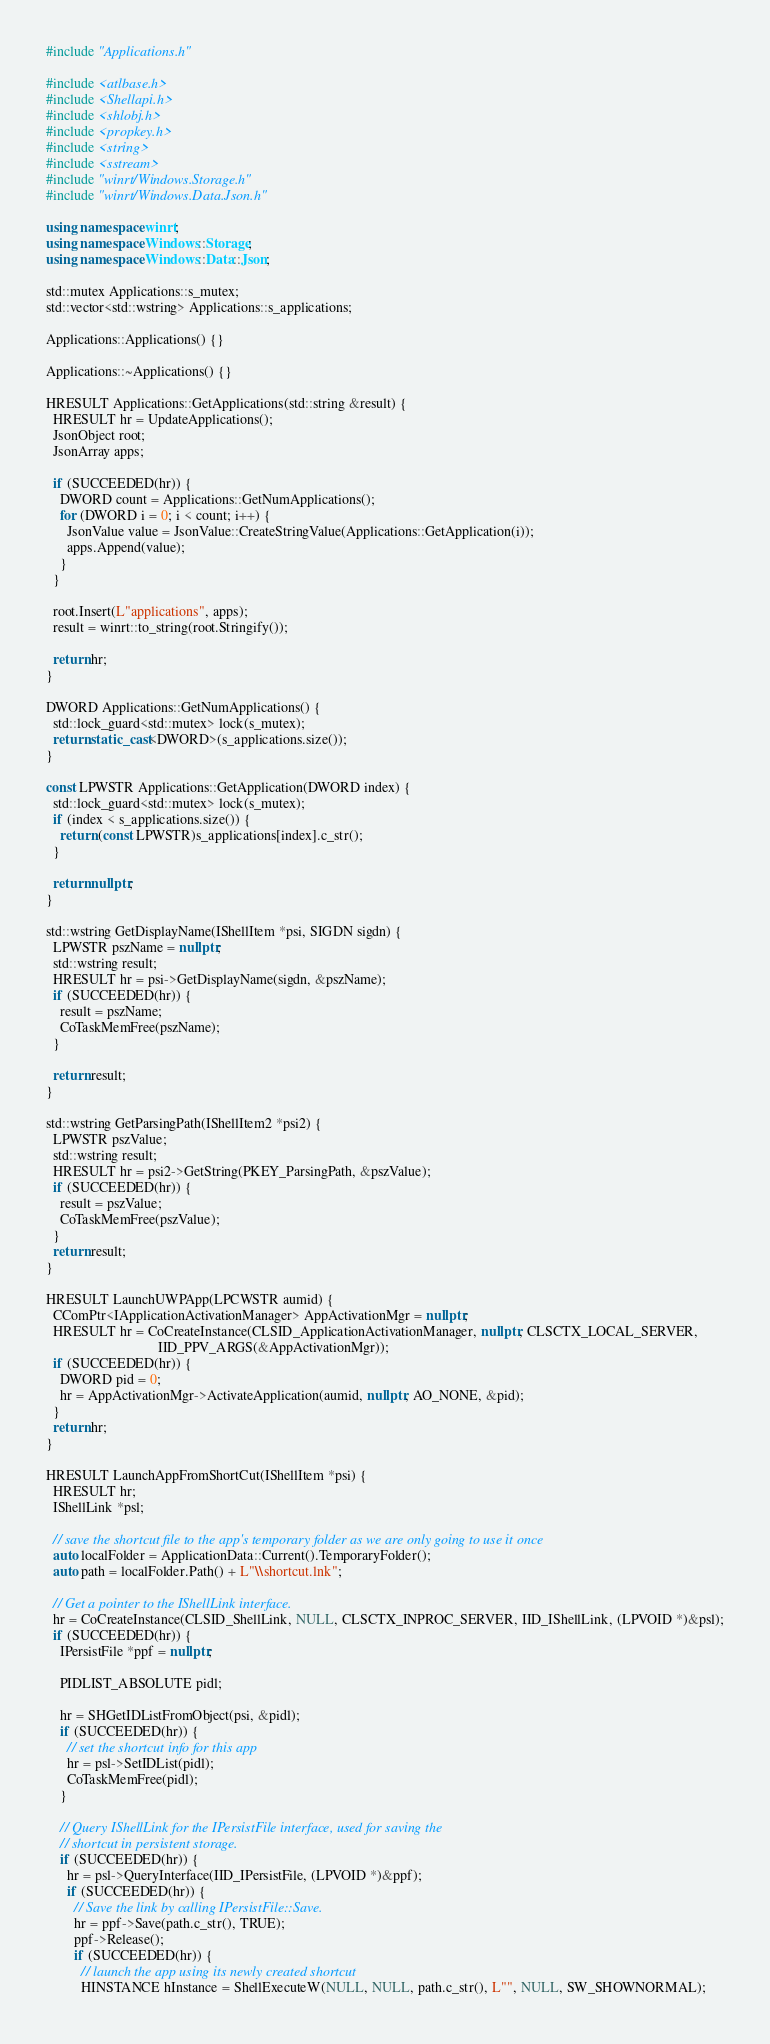<code> <loc_0><loc_0><loc_500><loc_500><_C++_>#include "Applications.h"

#include <atlbase.h>
#include <Shellapi.h>
#include <shlobj.h>
#include <propkey.h>
#include <string>
#include <sstream>
#include "winrt/Windows.Storage.h"
#include "winrt/Windows.Data.Json.h"

using namespace winrt;
using namespace Windows::Storage;
using namespace Windows::Data::Json;

std::mutex Applications::s_mutex;
std::vector<std::wstring> Applications::s_applications;

Applications::Applications() {}

Applications::~Applications() {}

HRESULT Applications::GetApplications(std::string &result) {
  HRESULT hr = UpdateApplications();
  JsonObject root;
  JsonArray apps;

  if (SUCCEEDED(hr)) {
    DWORD count = Applications::GetNumApplications();
    for (DWORD i = 0; i < count; i++) {
      JsonValue value = JsonValue::CreateStringValue(Applications::GetApplication(i));
      apps.Append(value);
    }
  }

  root.Insert(L"applications", apps);
  result = winrt::to_string(root.Stringify());

  return hr;
}

DWORD Applications::GetNumApplications() {
  std::lock_guard<std::mutex> lock(s_mutex);
  return static_cast<DWORD>(s_applications.size());
}

const LPWSTR Applications::GetApplication(DWORD index) {
  std::lock_guard<std::mutex> lock(s_mutex);
  if (index < s_applications.size()) {
    return (const LPWSTR)s_applications[index].c_str();
  }

  return nullptr;
}

std::wstring GetDisplayName(IShellItem *psi, SIGDN sigdn) {
  LPWSTR pszName = nullptr;
  std::wstring result;
  HRESULT hr = psi->GetDisplayName(sigdn, &pszName);
  if (SUCCEEDED(hr)) {
    result = pszName;
    CoTaskMemFree(pszName);
  }

  return result;
}

std::wstring GetParsingPath(IShellItem2 *psi2) {
  LPWSTR pszValue;
  std::wstring result;
  HRESULT hr = psi2->GetString(PKEY_ParsingPath, &pszValue);
  if (SUCCEEDED(hr)) {
    result = pszValue;
    CoTaskMemFree(pszValue);
  }
  return result;
}

HRESULT LaunchUWPApp(LPCWSTR aumid) {
  CComPtr<IApplicationActivationManager> AppActivationMgr = nullptr;
  HRESULT hr = CoCreateInstance(CLSID_ApplicationActivationManager, nullptr, CLSCTX_LOCAL_SERVER,
                                IID_PPV_ARGS(&AppActivationMgr));
  if (SUCCEEDED(hr)) {
    DWORD pid = 0;
    hr = AppActivationMgr->ActivateApplication(aumid, nullptr, AO_NONE, &pid);
  }
  return hr;
}

HRESULT LaunchAppFromShortCut(IShellItem *psi) {
  HRESULT hr;
  IShellLink *psl;

  // save the shortcut file to the app's temporary folder as we are only going to use it once
  auto localFolder = ApplicationData::Current().TemporaryFolder();
  auto path = localFolder.Path() + L"\\shortcut.lnk";

  // Get a pointer to the IShellLink interface.
  hr = CoCreateInstance(CLSID_ShellLink, NULL, CLSCTX_INPROC_SERVER, IID_IShellLink, (LPVOID *)&psl);
  if (SUCCEEDED(hr)) {
    IPersistFile *ppf = nullptr;

    PIDLIST_ABSOLUTE pidl;

    hr = SHGetIDListFromObject(psi, &pidl);
    if (SUCCEEDED(hr)) {
      // set the shortcut info for this app
      hr = psl->SetIDList(pidl);
      CoTaskMemFree(pidl);
    }

    // Query IShellLink for the IPersistFile interface, used for saving the
    // shortcut in persistent storage.
    if (SUCCEEDED(hr)) {
      hr = psl->QueryInterface(IID_IPersistFile, (LPVOID *)&ppf);
      if (SUCCEEDED(hr)) {
        // Save the link by calling IPersistFile::Save.
        hr = ppf->Save(path.c_str(), TRUE);
        ppf->Release();
        if (SUCCEEDED(hr)) {
          // launch the app using its newly created shortcut
          HINSTANCE hInstance = ShellExecuteW(NULL, NULL, path.c_str(), L"", NULL, SW_SHOWNORMAL);</code> 